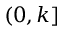<formula> <loc_0><loc_0><loc_500><loc_500>( 0 , k ]</formula> 